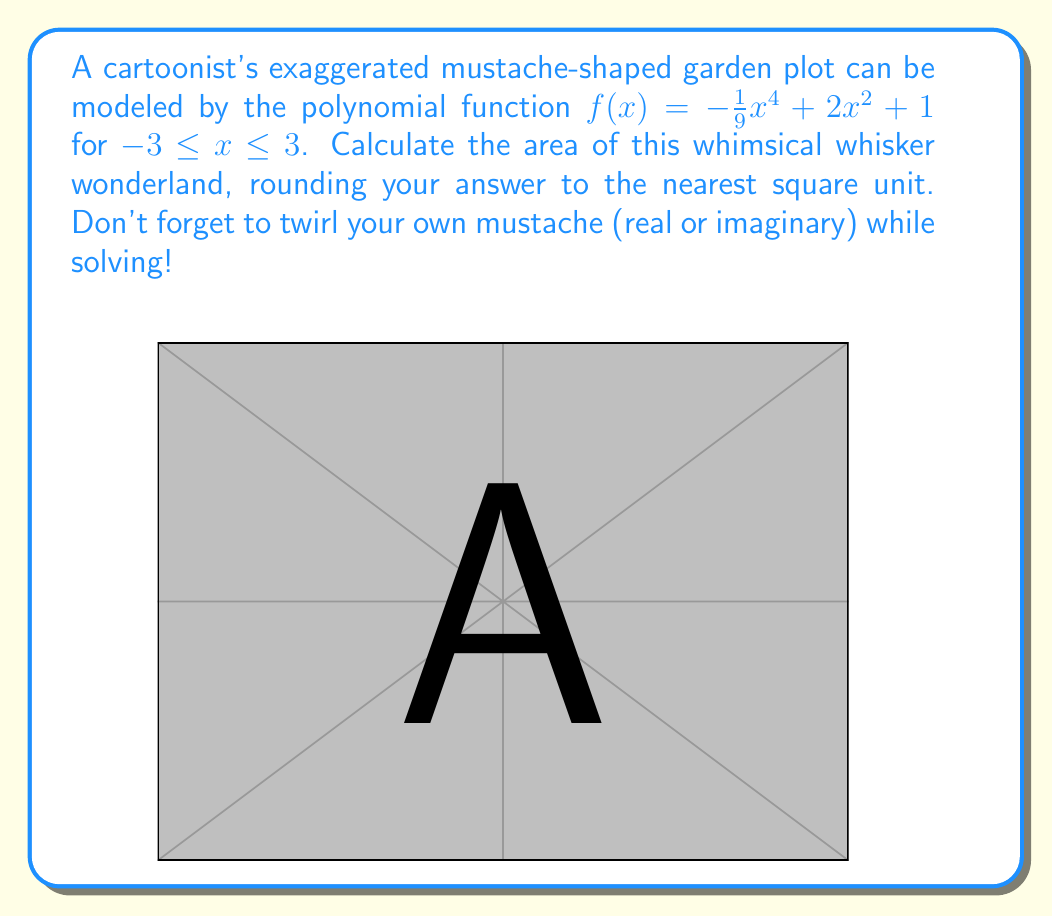Give your solution to this math problem. Let's groom this hairy problem step by step:

1) The area under a curve is given by the definite integral. In this case:

   $$A = \int_{-3}^{3} f(x) dx = \int_{-3}^{3} (-\frac{1}{9}x^4 + 2x^2 + 1) dx$$

2) Let's integrate term by term:

   $$A = \left[-\frac{1}{45}x^5 + \frac{2}{3}x^3 + x\right]_{-3}^{3}$$

3) Now, let's evaluate the integral at the bounds:

   $$A = \left(-\frac{1}{45}(3^5) + \frac{2}{3}(3^3) + 3\right) - \left(-\frac{1}{45}(-3^5) + \frac{2}{3}(-3^3) + (-3)\right)$$

4) Simplify:

   $$A = \left(-\frac{243}{45} + 18 + 3\right) - \left(\frac{243}{45} - 18 - 3\right)$$

   $$A = \left(-\frac{243}{45} + 21\right) - \left(\frac{243}{45} - 21\right)$$

5) Combine like terms:

   $$A = \left(-\frac{243}{45} + 21\right) + \left(-\frac{243}{45} + 21\right) = -\frac{486}{45} + 42$$

6) Simplify:

   $$A = -\frac{486}{45} + \frac{1890}{45} = \frac{1404}{45} = 31.2$$

7) Rounding to the nearest whole number:

   $$A \approx 31 \text{ square units}$$

And there you have it! A perfectly groomed solution for our mustache garden.
Answer: 31 square units 